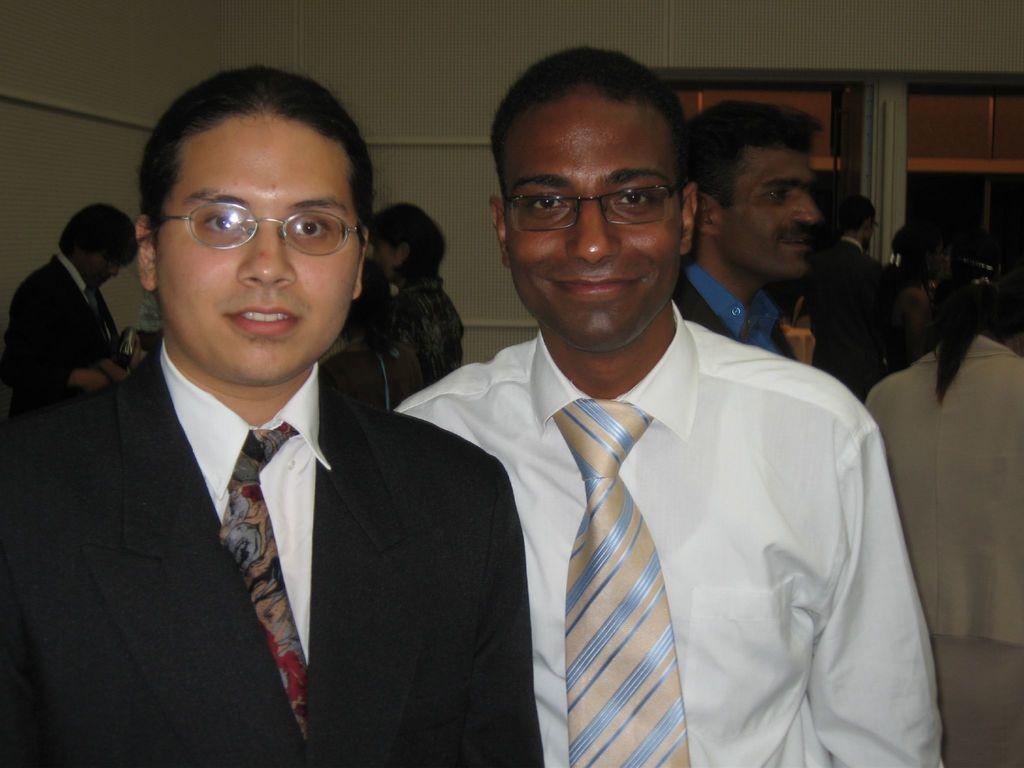In one or two sentences, can you explain what this image depicts? In this image I can see group of people standing. In front the person is wearing black blazer, white shirt and the person at right is wearing white shirt, blue and cream color tie. Background I can see few windows and the wall is in cream color. 